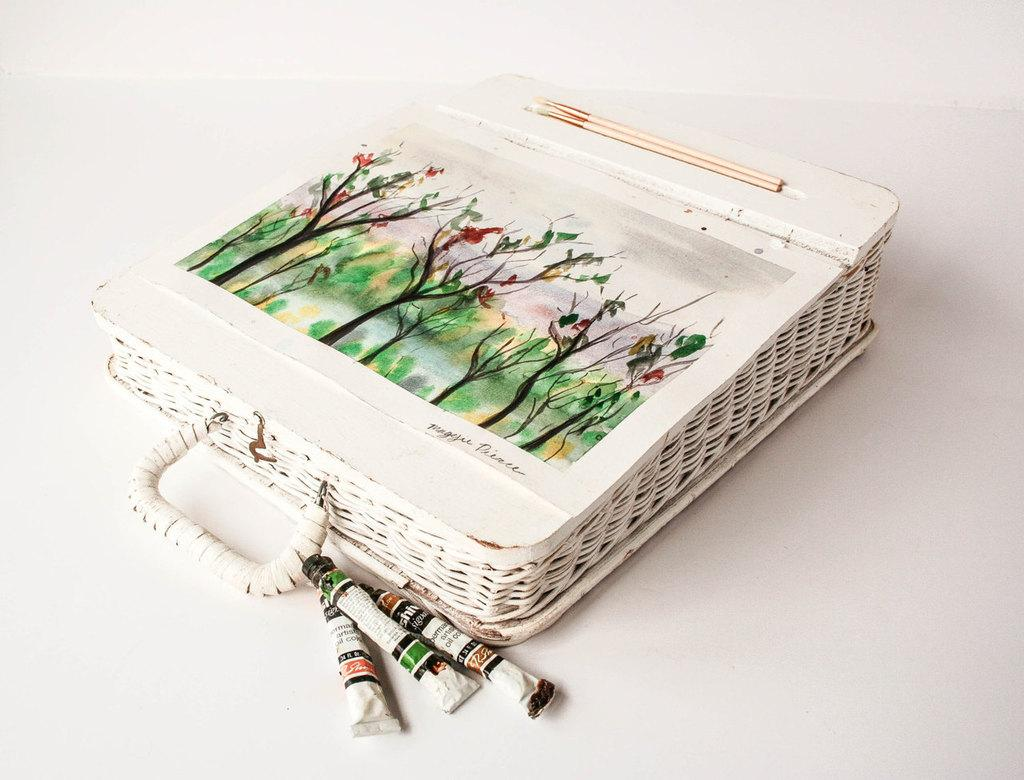What is the main color of the object in the picture? The main color of the object in the picture is white. What is depicted on the white object? The white object has a painting on it. What can be seen near the painting on the white object? There are paint tubes visible on the white object. What is the weather like in the image? The provided facts do not mention any information about the weather, so it cannot be determined from the image. 